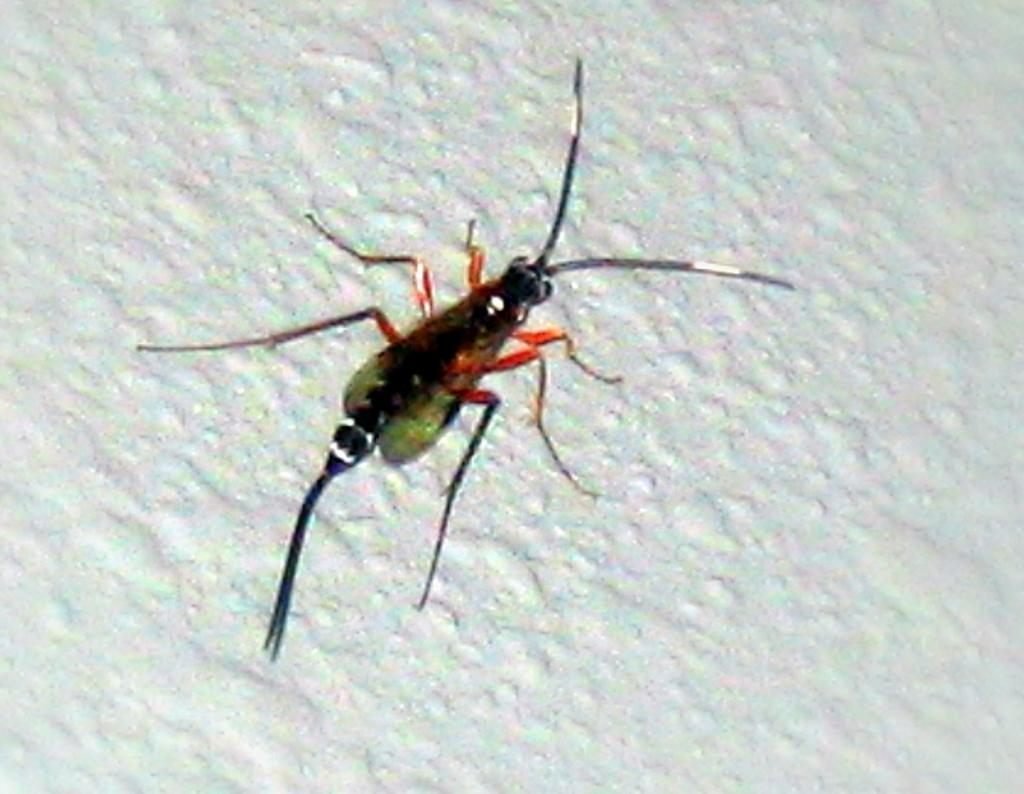What is present on the white surface in the image? There is an insect in the image. Can you describe the surface on which the insect is located? The insect is on a white surface. What type of locket is the insect wearing in the image? There is no locket present in the image, as the insect is not wearing any jewelry. What is the insect's tendency to move in the image? The image does not show the insect moving, so it is not possible to determine its tendency to move. 